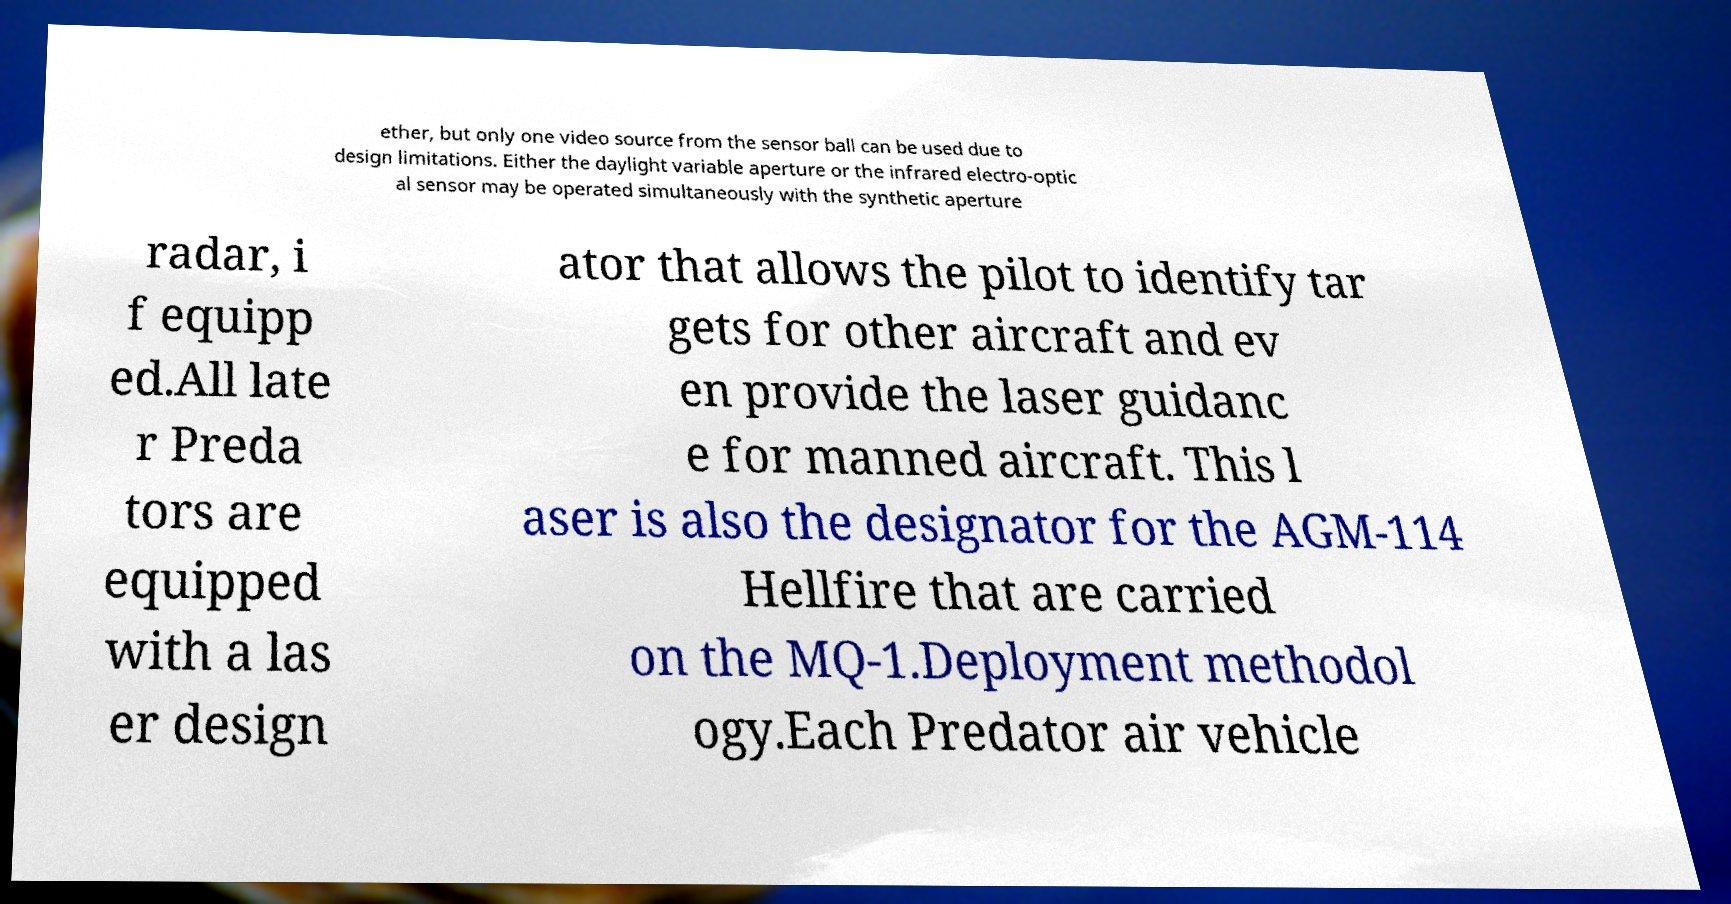Can you accurately transcribe the text from the provided image for me? ether, but only one video source from the sensor ball can be used due to design limitations. Either the daylight variable aperture or the infrared electro-optic al sensor may be operated simultaneously with the synthetic aperture radar, i f equipp ed.All late r Preda tors are equipped with a las er design ator that allows the pilot to identify tar gets for other aircraft and ev en provide the laser guidanc e for manned aircraft. This l aser is also the designator for the AGM-114 Hellfire that are carried on the MQ-1.Deployment methodol ogy.Each Predator air vehicle 